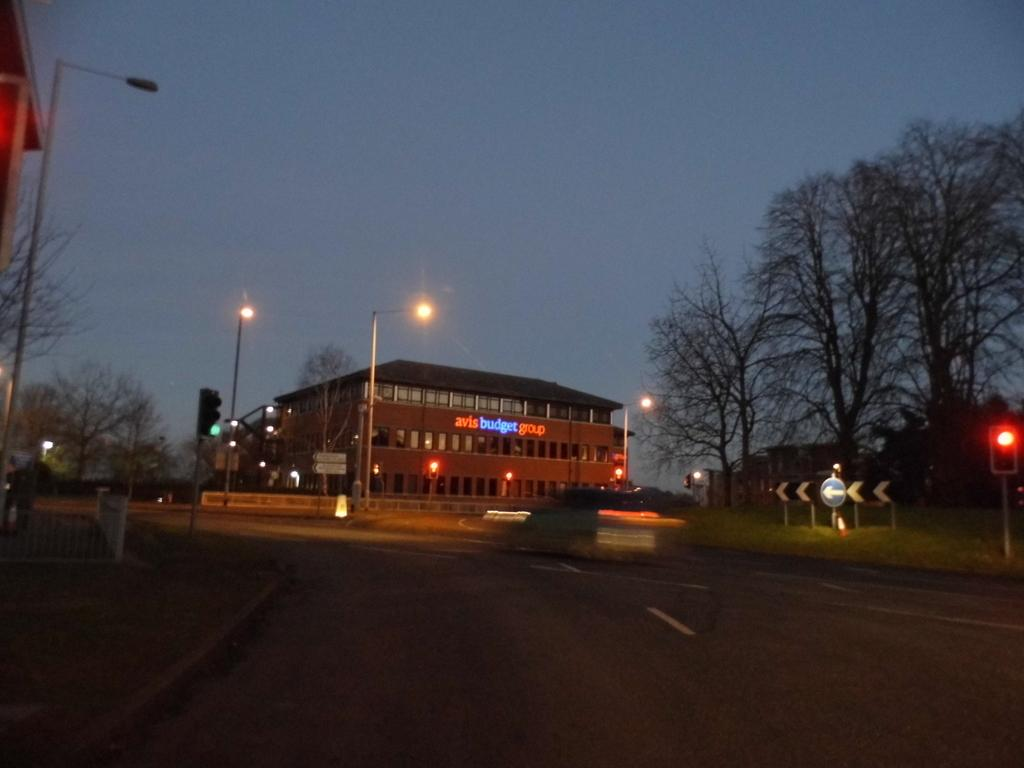What type of structures can be seen in the image? There are buildings in the image. What other natural elements are present in the image? There are trees in the image. What type of illumination is visible in the image? There are lights in the image. What type of vertical structures can be seen in the image? There are poles in the image. What type of signage is present in the image? There are boards in the image. What type of barrier is present in the image? There is a fence in the image. What part of the natural environment is visible in the image? The sky is visible at the top of the image. What type of man-made surface is visible at the bottom of the image? There is a road visible at the bottom of the image. Can you tell me how many women are operating the machine in the image? There is no machine or woman present in the image. What type of uncle is standing near the fence in the image? There is no uncle present in the image. 